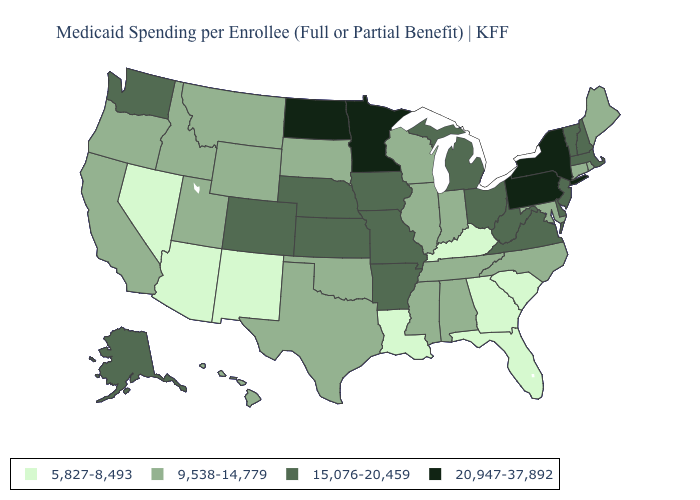Name the states that have a value in the range 20,947-37,892?
Quick response, please. Minnesota, New York, North Dakota, Pennsylvania. Name the states that have a value in the range 5,827-8,493?
Answer briefly. Arizona, Florida, Georgia, Kentucky, Louisiana, Nevada, New Mexico, South Carolina. Among the states that border Virginia , does Kentucky have the lowest value?
Concise answer only. Yes. Does Maine have the highest value in the Northeast?
Quick response, please. No. What is the highest value in states that border Maine?
Quick response, please. 15,076-20,459. What is the value of North Carolina?
Keep it brief. 9,538-14,779. Among the states that border Idaho , which have the highest value?
Answer briefly. Washington. Name the states that have a value in the range 9,538-14,779?
Be succinct. Alabama, California, Connecticut, Hawaii, Idaho, Illinois, Indiana, Maine, Maryland, Mississippi, Montana, North Carolina, Oklahoma, Oregon, Rhode Island, South Dakota, Tennessee, Texas, Utah, Wisconsin, Wyoming. Name the states that have a value in the range 5,827-8,493?
Concise answer only. Arizona, Florida, Georgia, Kentucky, Louisiana, Nevada, New Mexico, South Carolina. Which states have the lowest value in the West?
Be succinct. Arizona, Nevada, New Mexico. What is the value of Wyoming?
Concise answer only. 9,538-14,779. Does Florida have the lowest value in the USA?
Quick response, please. Yes. Is the legend a continuous bar?
Quick response, please. No. What is the value of North Carolina?
Answer briefly. 9,538-14,779. Name the states that have a value in the range 5,827-8,493?
Give a very brief answer. Arizona, Florida, Georgia, Kentucky, Louisiana, Nevada, New Mexico, South Carolina. 